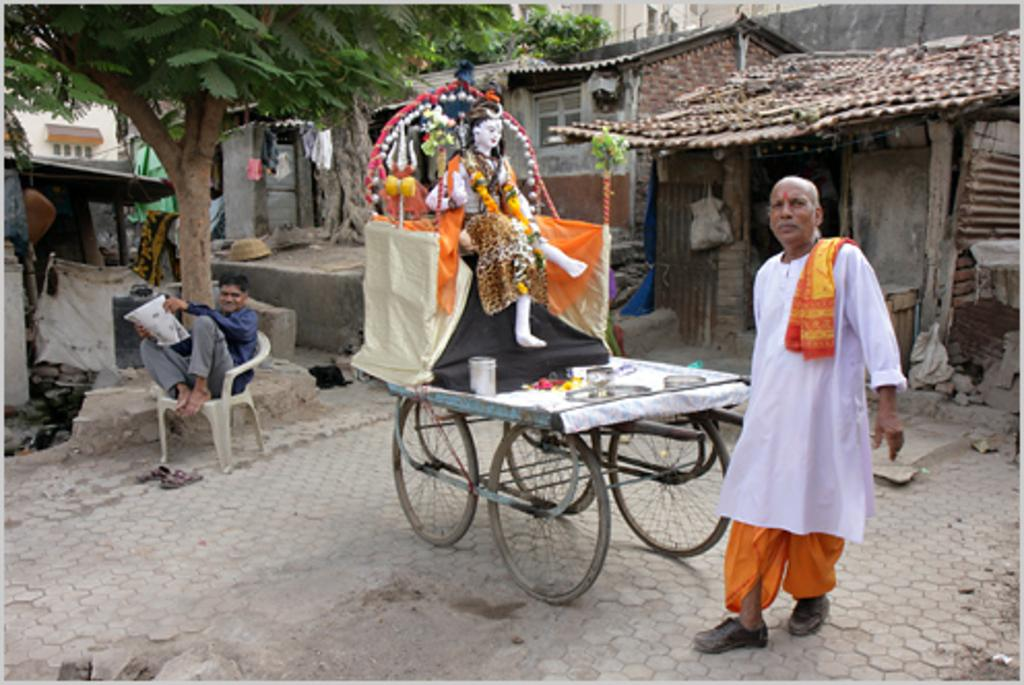What is the main subject of the image? There is a person standing near a vehicle in the image. Can you describe the position of another person in the image? There is a person sitting on a chair in the image. What can be seen in the background of the image? Trees and houses are visible in the background of the image. What type of land can be seen in the image? There is no specific type of land mentioned or visible in the image. Can you tell me if there is an airport in the image? There is no airport visible in the image. 